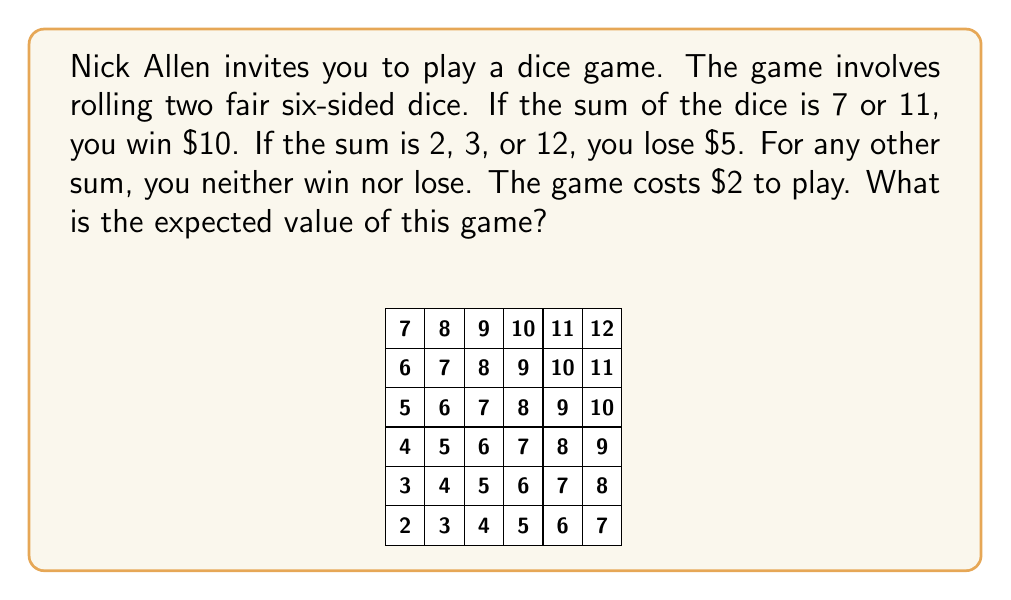Could you help me with this problem? Let's approach this step-by-step:

1) First, we need to calculate the probabilities of each outcome:
   
   P(sum = 7) = 6/36 = 1/6
   P(sum = 11) = 2/36 = 1/18
   P(sum = 2) = 1/36
   P(sum = 3) = 2/36 = 1/18
   P(sum = 12) = 1/36

2) Now, let's calculate the expected value of winnings:
   
   E(win) = $10 * P(sum = 7 or 11) = $10 * (1/6 + 1/18) = $10 * (3/18 + 1/18) = $10 * 4/18 = $20/9

3) Next, the expected value of losses:
   
   E(loss) = $5 * P(sum = 2 or 3 or 12) = $5 * (1/36 + 1/18 + 1/36) = $5 * 4/36 = $5/9

4) The expected value of the game before considering the cost to play is:
   
   E(game) = E(win) - E(loss) = $20/9 - $5/9 = $15/9

5) However, the game costs $2 to play. So we need to subtract this from our expected value:
   
   E(final) = E(game) - cost = $15/9 - $2 = $15/9 - $18/9 = -$3/9 = -$1/3

Therefore, the expected value of the game is -$1/3 or approximately -$0.33.
Answer: $$-\frac{1}{3}$$ or $$-$0.33$$ 